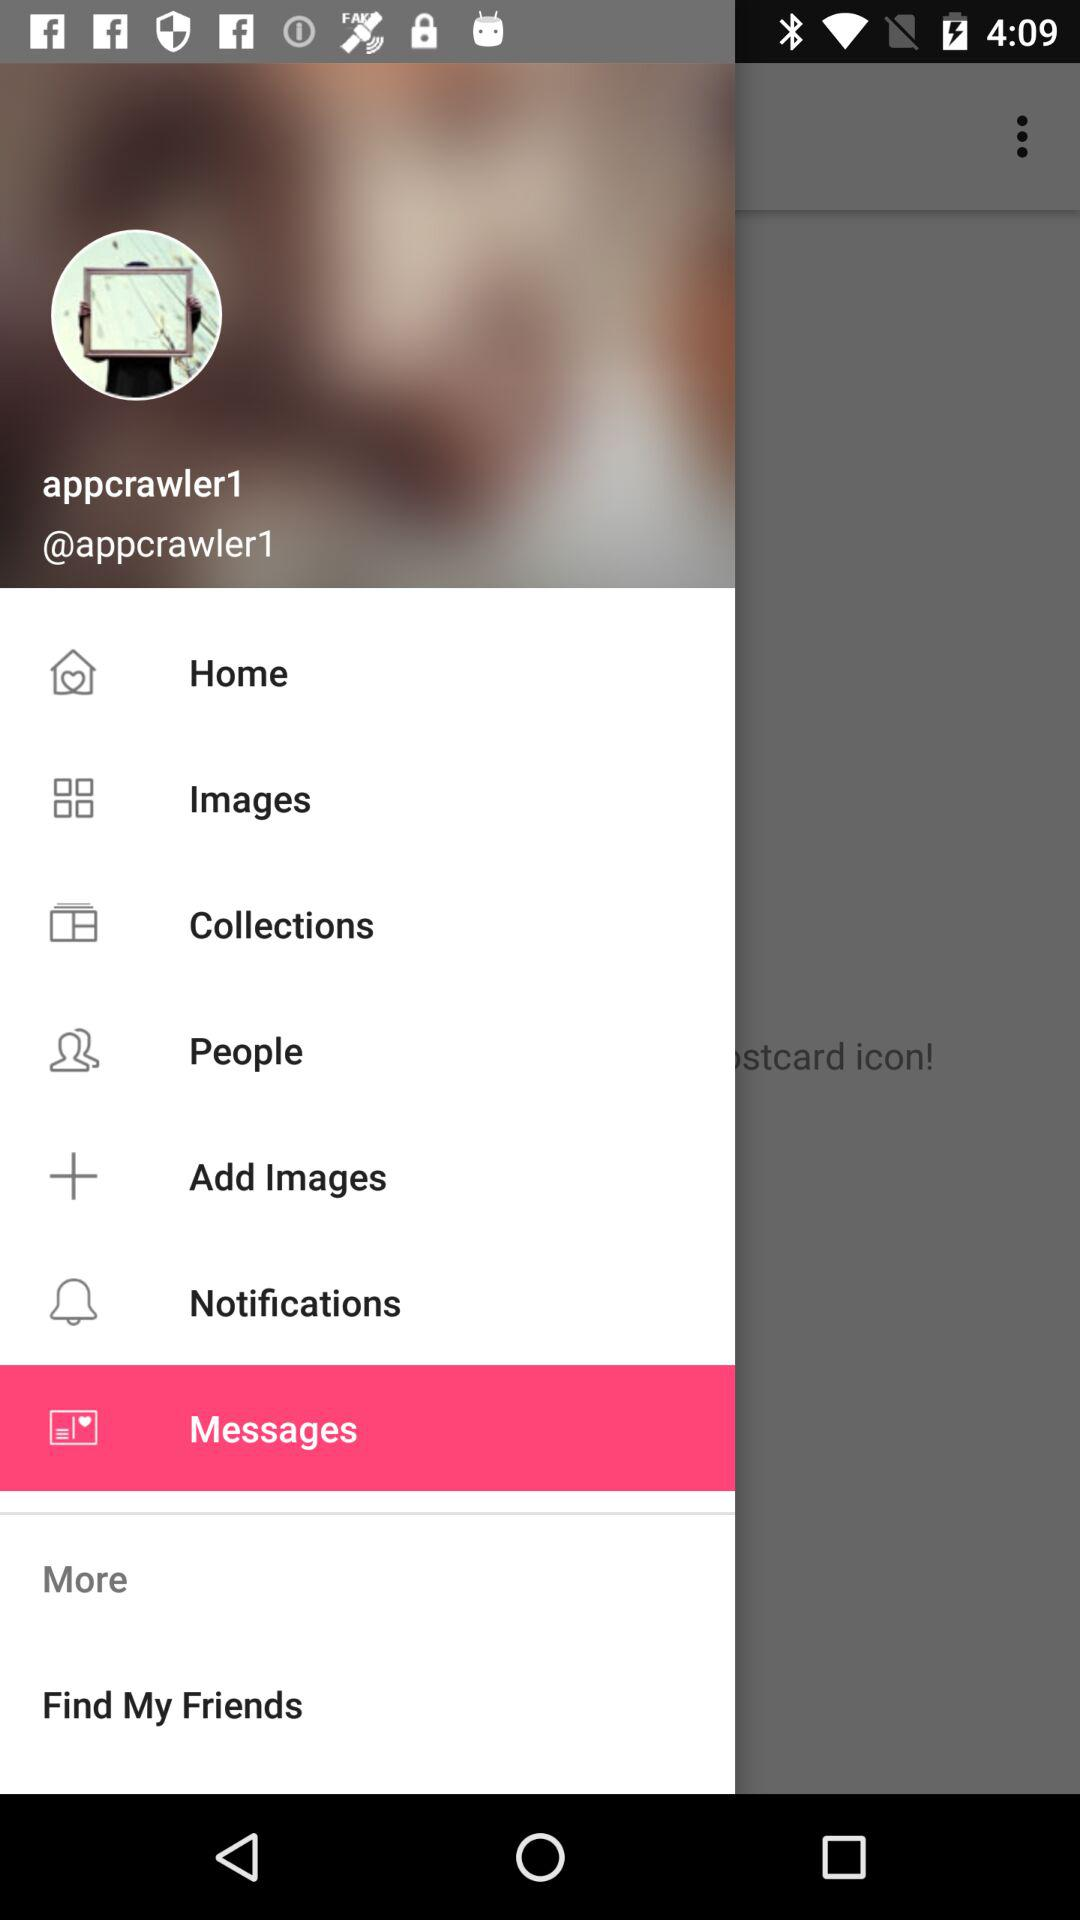How many collections are there?
When the provided information is insufficient, respond with <no answer>. <no answer> 